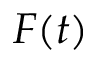<formula> <loc_0><loc_0><loc_500><loc_500>F ( t )</formula> 